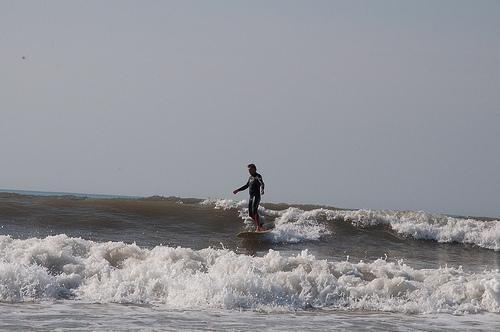How many surfers are there?
Give a very brief answer. 1. 